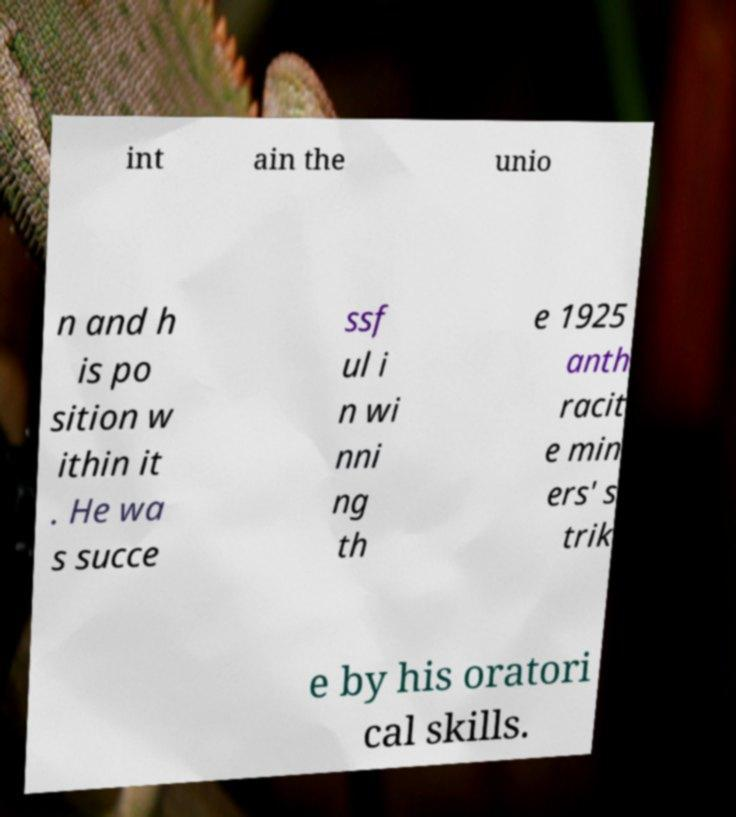Please identify and transcribe the text found in this image. int ain the unio n and h is po sition w ithin it . He wa s succe ssf ul i n wi nni ng th e 1925 anth racit e min ers' s trik e by his oratori cal skills. 